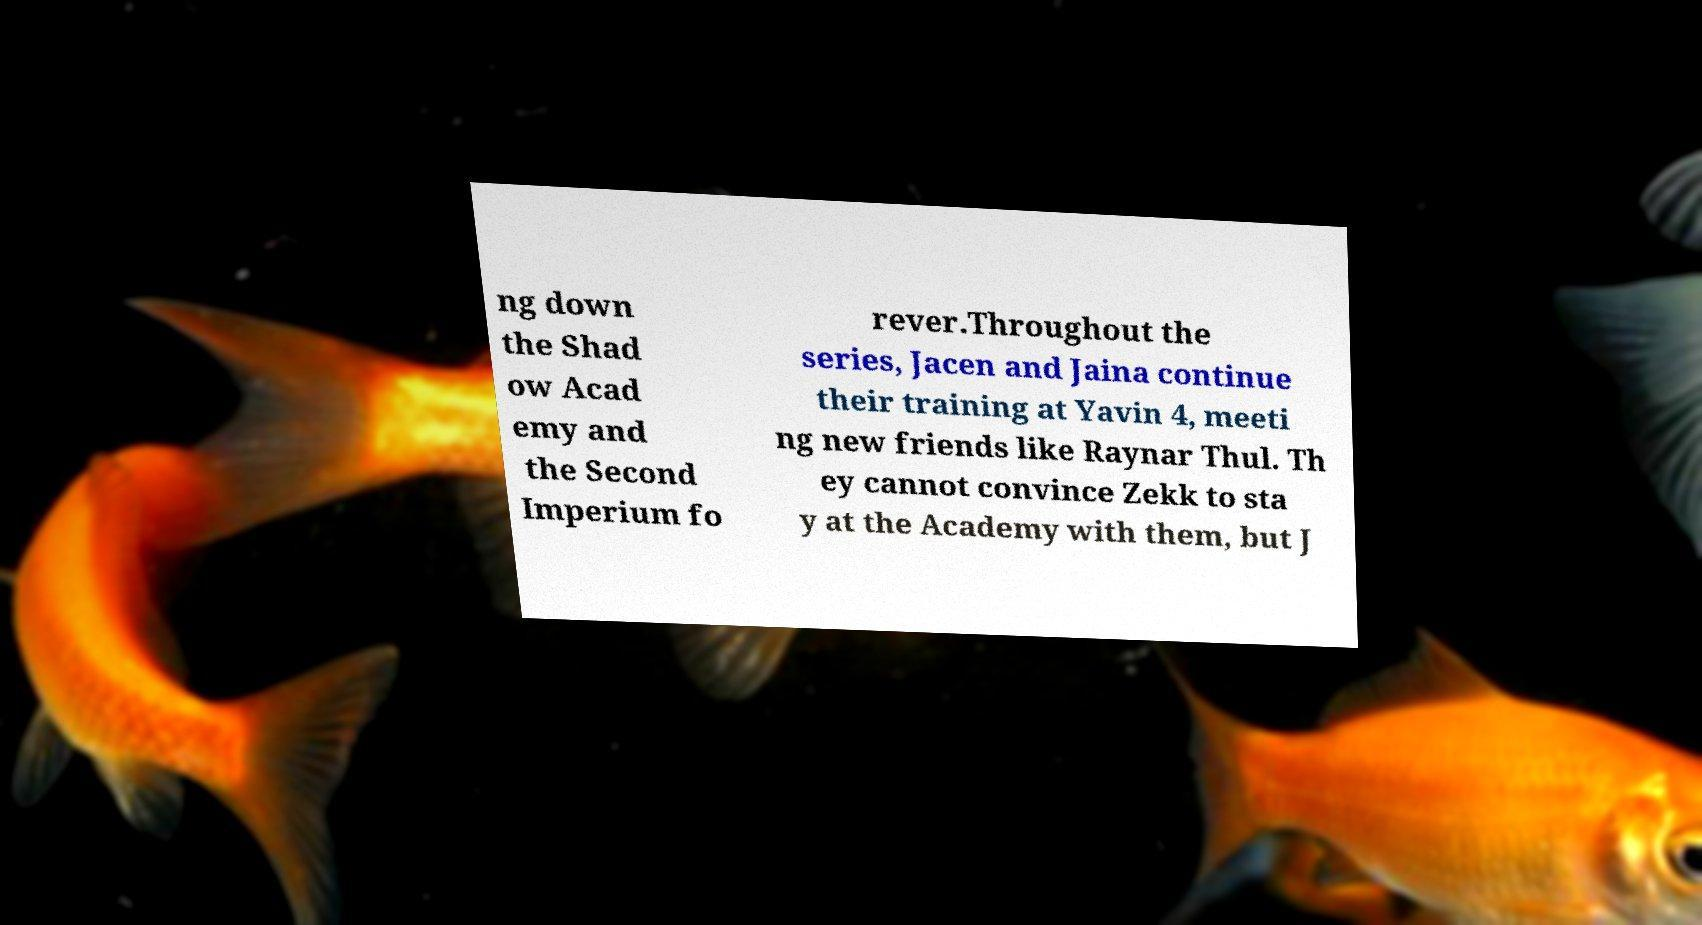What messages or text are displayed in this image? I need them in a readable, typed format. ng down the Shad ow Acad emy and the Second Imperium fo rever.Throughout the series, Jacen and Jaina continue their training at Yavin 4, meeti ng new friends like Raynar Thul. Th ey cannot convince Zekk to sta y at the Academy with them, but J 